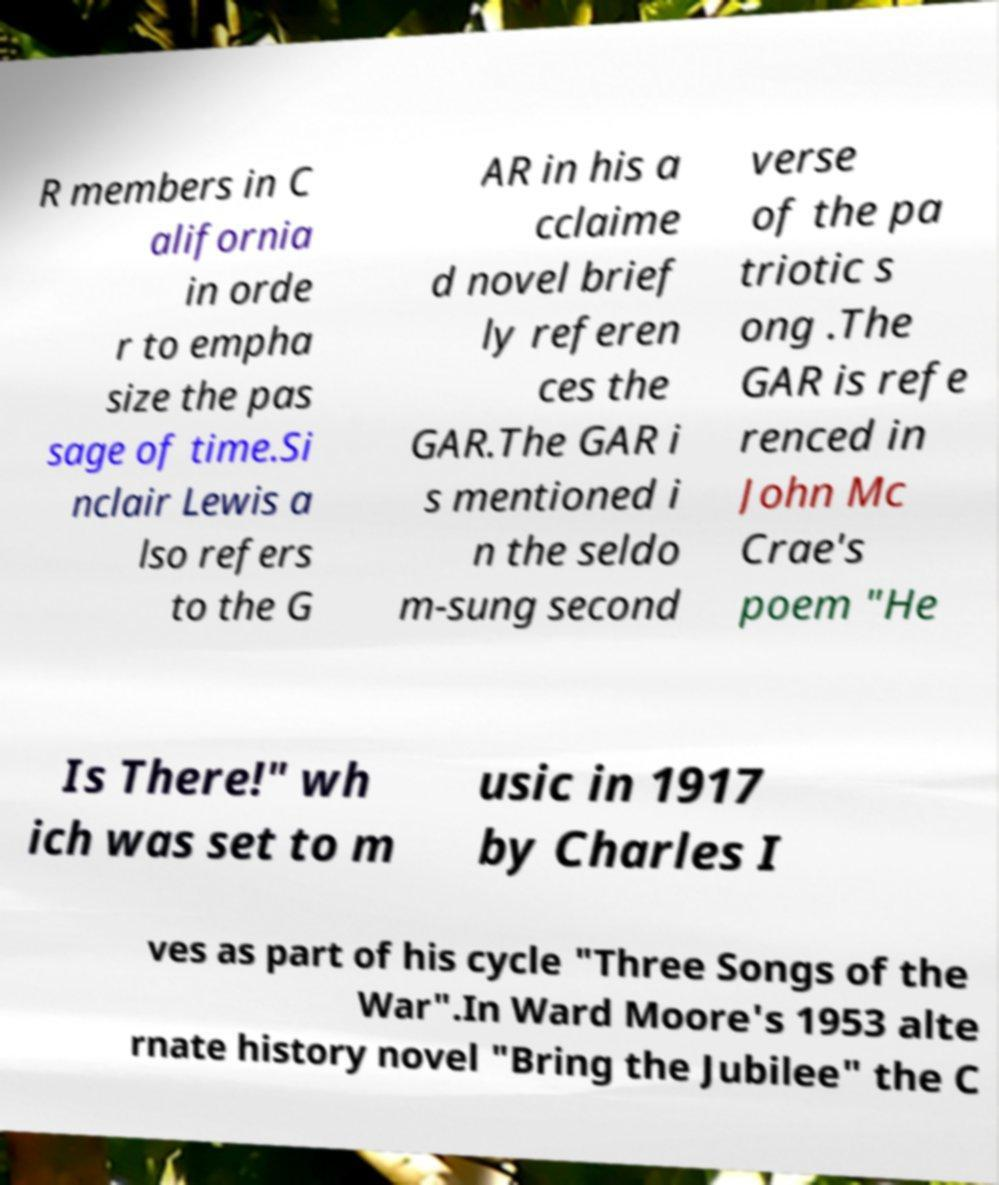Can you read and provide the text displayed in the image?This photo seems to have some interesting text. Can you extract and type it out for me? R members in C alifornia in orde r to empha size the pas sage of time.Si nclair Lewis a lso refers to the G AR in his a cclaime d novel brief ly referen ces the GAR.The GAR i s mentioned i n the seldo m-sung second verse of the pa triotic s ong .The GAR is refe renced in John Mc Crae's poem "He Is There!" wh ich was set to m usic in 1917 by Charles I ves as part of his cycle "Three Songs of the War".In Ward Moore's 1953 alte rnate history novel "Bring the Jubilee" the C 